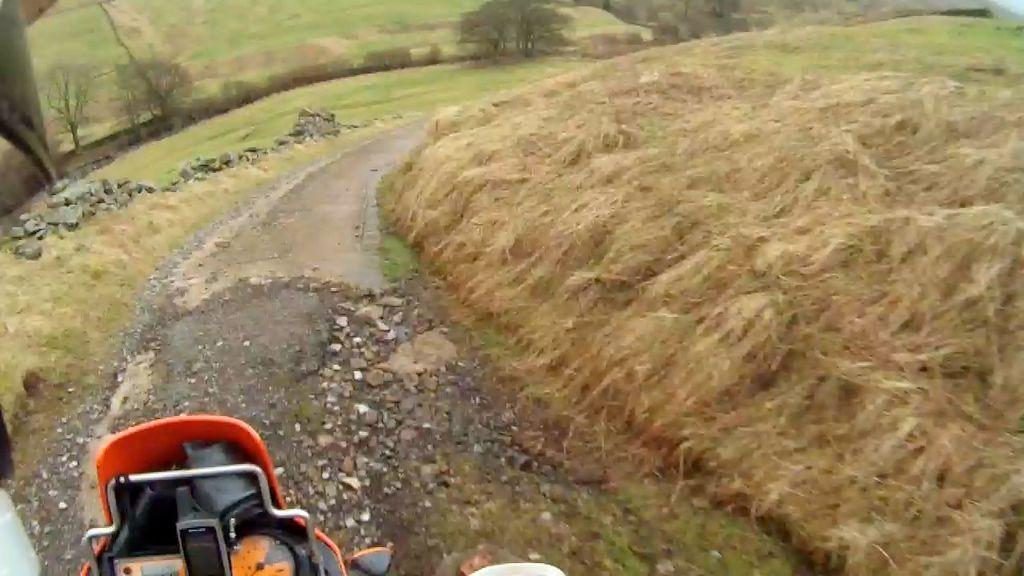What type of surface can be seen in the image? There is a road in the image. What type of vegetation is visible in the image? Grass, trees, and plants are present in the image. What material is present in the image? Stone is present in the image. Where is the vehicle odometer located in the image? The vehicle odometer is on the left side of the image. What else can be seen on the left side of the image? There are some objects on the left side of the image. What letter is visible on the boot in the image? There is no boot or letter present in the image. How many quarters are visible in the image? There are no quarters present in the image. 